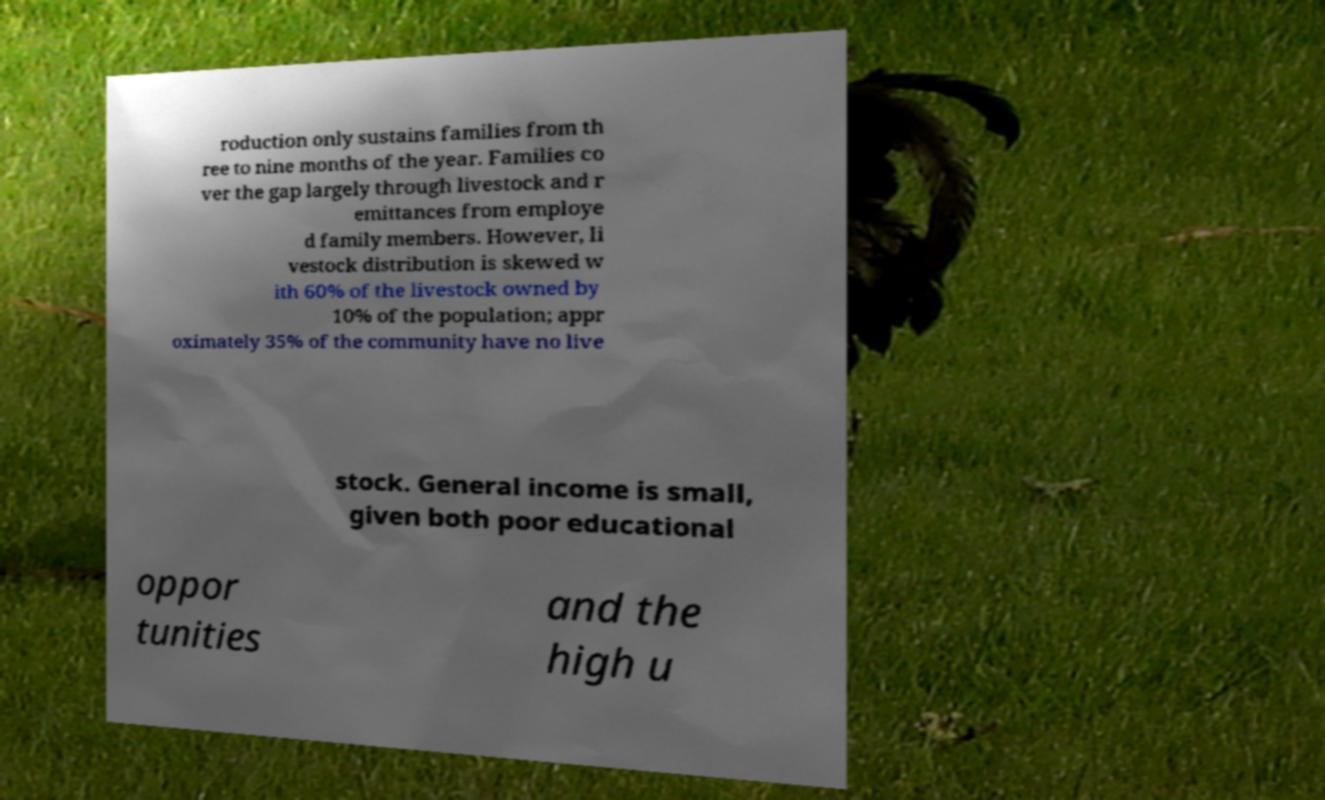What messages or text are displayed in this image? I need them in a readable, typed format. roduction only sustains families from th ree to nine months of the year. Families co ver the gap largely through livestock and r emittances from employe d family members. However, li vestock distribution is skewed w ith 60% of the livestock owned by 10% of the population; appr oximately 35% of the community have no live stock. General income is small, given both poor educational oppor tunities and the high u 